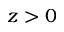Convert formula to latex. <formula><loc_0><loc_0><loc_500><loc_500>z > 0</formula> 